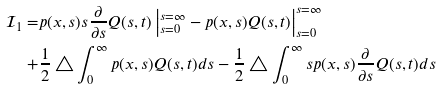<formula> <loc_0><loc_0><loc_500><loc_500>\mathcal { I } _ { 1 } = & p ( x , s ) s \frac { \partial } { \partial s } Q ( s , t ) \left | _ { s = 0 } ^ { s = \infty } - p ( x , s ) Q ( s , t ) \right | _ { s = 0 } ^ { s = \infty } \\ + & \frac { 1 } { 2 } \triangle \int _ { 0 } ^ { \infty } p ( x , s ) Q ( s , t ) d s - \frac { 1 } { 2 } \triangle \int _ { 0 } ^ { \infty } s p ( x , s ) \frac { \partial } { \partial s } Q ( s , t ) d s</formula> 